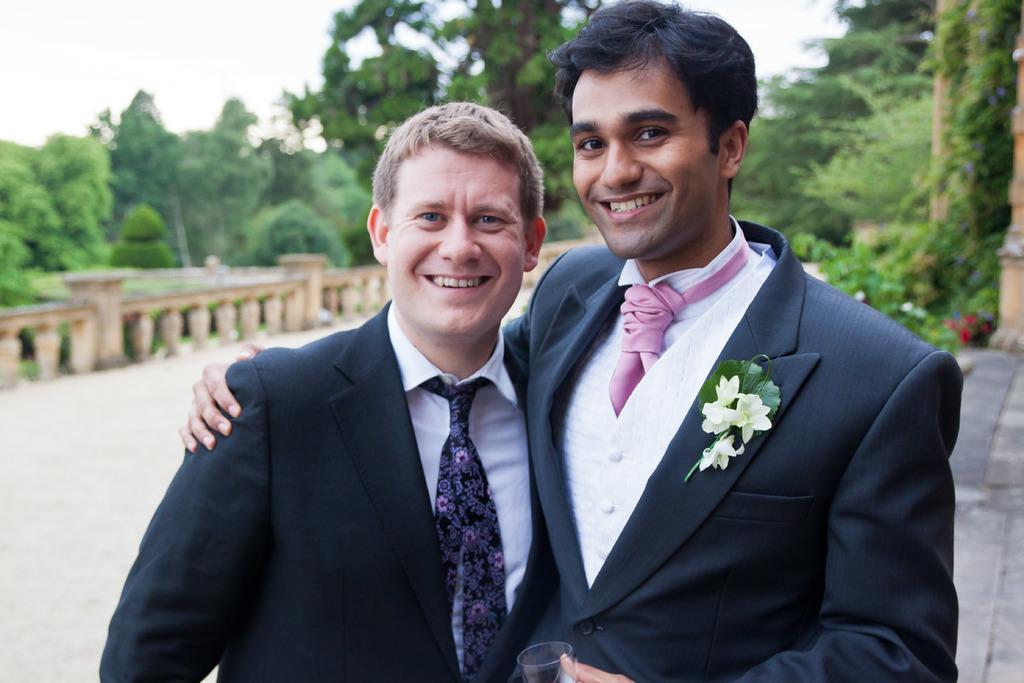Please provide a concise description of this image. In this image I can see two men in the front and I can see both of them are wearing formal dress, I can also see smile on their faces. In the background I can see number of trees, flowers and I can see this image is little bit blurry in the background. 